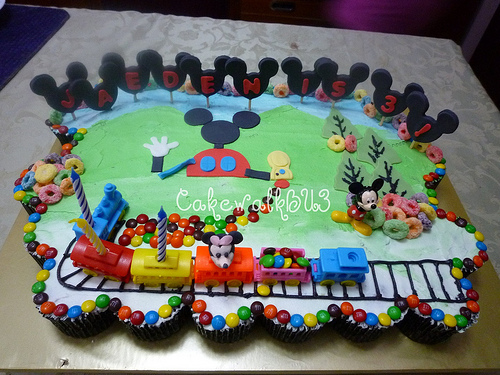<image>
Is there a candy behind the train? No. The candy is not behind the train. From this viewpoint, the candy appears to be positioned elsewhere in the scene. 